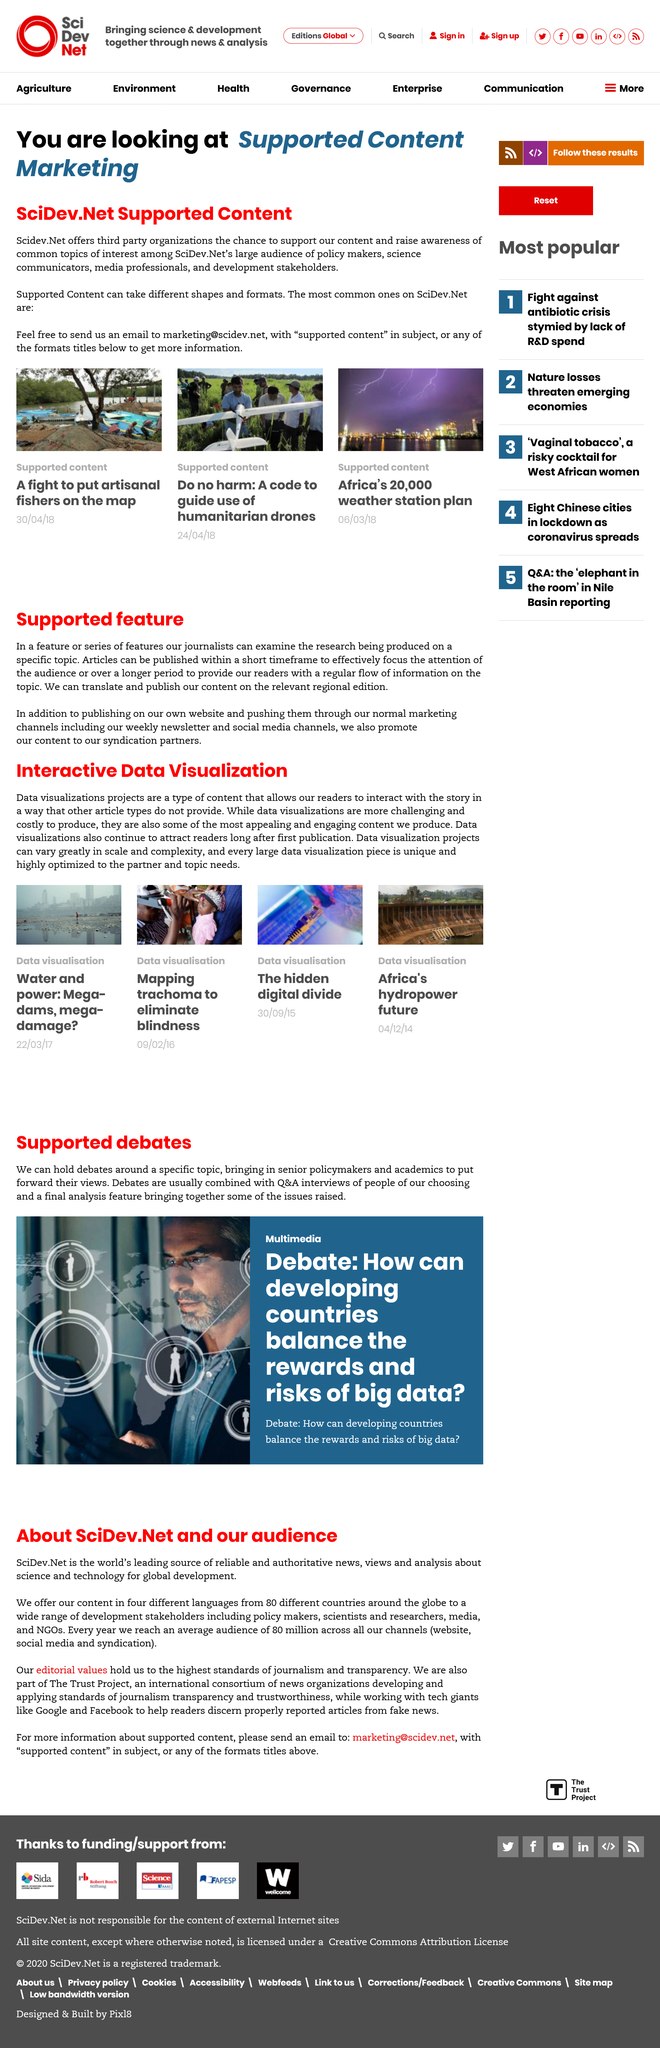Draw attention to some important aspects in this diagram. Data visualization projects are a type of content that presents information in a visual format, enabling readers to interact with the story and gain a deeper understanding of the subject matter. SciDev.Net attracts a diverse audience consisting of policy makers, science communicators, media professionals, and development stakeholders from around the world. This article is classified as Supported Content Marketing. Yes, they can translate and publish their content on the relevant regional edition, and they also promote their content to syndication partners. Data visualizations are more challenging to produce than other forms of content. 